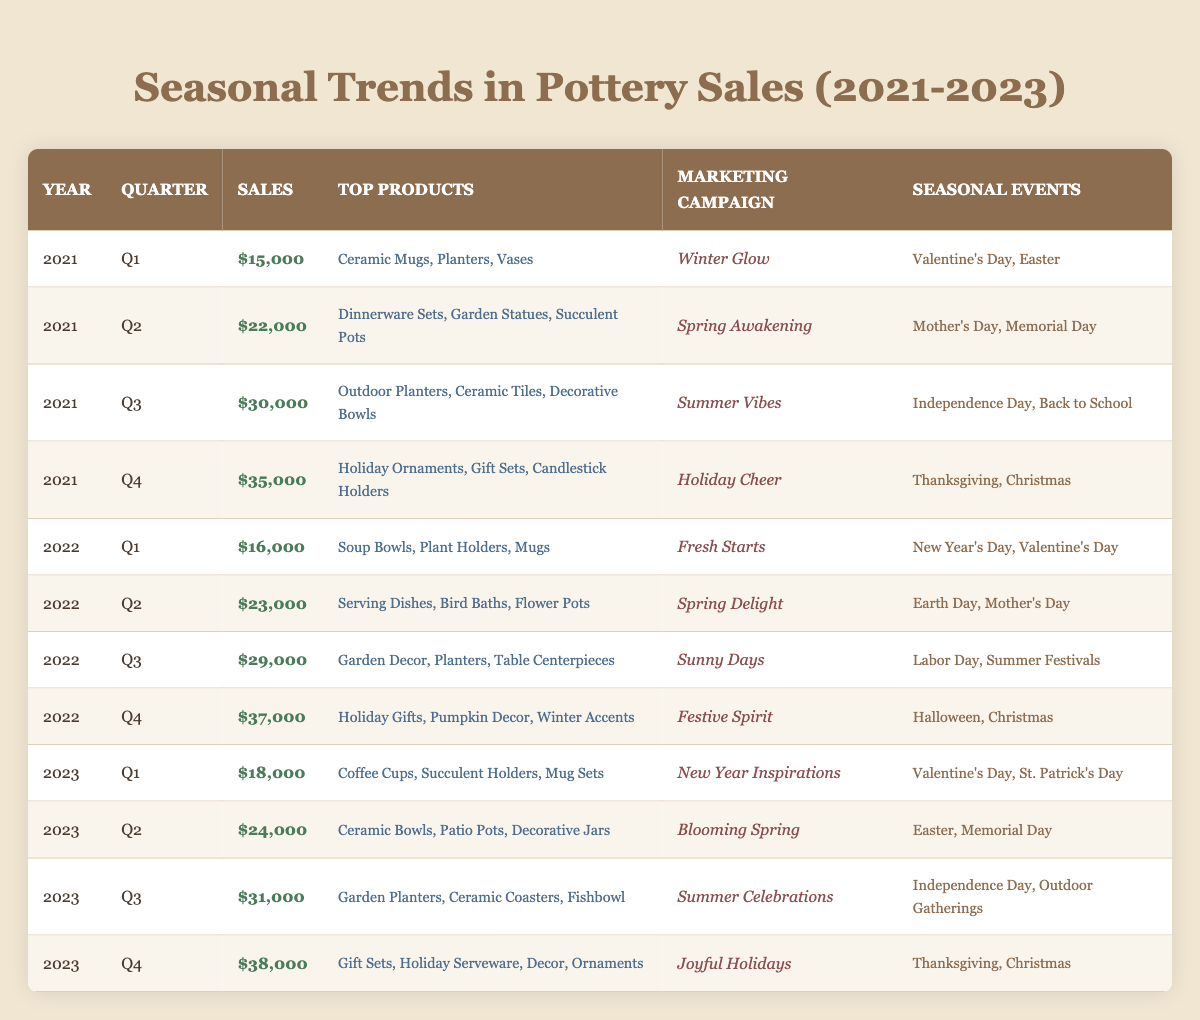What were the top products in Q4 of 2022? In Q4 of 2022, the top products listed were Holiday Gifts, Pumpkin Decor, and Winter Accents.
Answer: Holiday Gifts, Pumpkin Decor, Winter Accents Which quarter in 2023 had the highest sales? In 2023, Q4 had the highest sales at $38,000.
Answer: Q4 What was the total sales for the year 2021? The sales for each quarter of 2021 are: Q1 $15,000, Q2 $22,000, Q3 $30,000, and Q4 $35,000. Adding these gives $15,000 + $22,000 + $30,000 + $35,000 = $102,000.
Answer: $102,000 Did the sales in Q2 of 2022 increase compared to Q2 of 2021? In Q2 of 2022, sales were $23,000, and in Q2 of 2021, sales were $22,000. Since $23,000 is greater than $22,000, the sales did increase.
Answer: Yes What is the average sales per quarter for the year 2023? The total sales for 2023 are: Q1 $18,000, Q2 $24,000, Q3 $31,000, and Q4 $38,000. Adding these gives $18,000 + $24,000 + $31,000 + $38,000 = $111,000. To find the average, divide by 4, which results in $111,000 / 4 = $27,750.
Answer: $27,750 Which marketing campaign had the highest sales in 2022? The highest sales in 2022 occurred in Q4 with $37,000 under the marketing campaign Festive Spirit, which is higher than any other campaign that year.
Answer: Festive Spirit How many different top products were listed for Q3 across all years? For Q3 2021, the top products were Outdoor Planters, Ceramic Tiles, and Decorative Bowls (3 products). For Q3 2022, they were Garden Decor, Planters, and Table Centerpieces (3 products). In 2023, they were Garden Planters, Ceramic Coasters, and Fishbowl (3 products). Thus, the unique products across these three quarters are 3 + 3 + 3 = 9 products, but only 7 unique ones if removing duplicates.
Answer: 7 unique products Was the sales trend over the three years upward or downward? Analyzing the sales figures: Q1 in 2021 was $15,000, in 2022 was $16,000, and in 2023 was $18,000, showing an upward trend. The same applies for Q2, Q3, and Q4, where sales are increasing each year. This indicates a consistent upward trend in sales over the three years.
Answer: Upward trend Comparing Q2 of 2022 and Q2 of 2021, what was the percentage increase in sales? Q2 of 2021 had sales of $22,000, and Q2 of 2022 had sales of $23,000. To find the percentage increase, subtract the old number from the new number: $23,000 - $22,000 = $1,000. Then, divide by the old number and multiply by 100: ($1,000 / $22,000) * 100 = approximately 4.55%.
Answer: 4.55% In which quarter did marketing campaigns focus on holiday themes most significantly? In the data, both Q4 of 2021 and Q4 of 2022 had marketing campaigns centered around holiday themes, specifically "Holiday Cheer" for 2021 and "Festive Spirit" for 2022, indicating a strong holiday focus.
Answer: Q4 